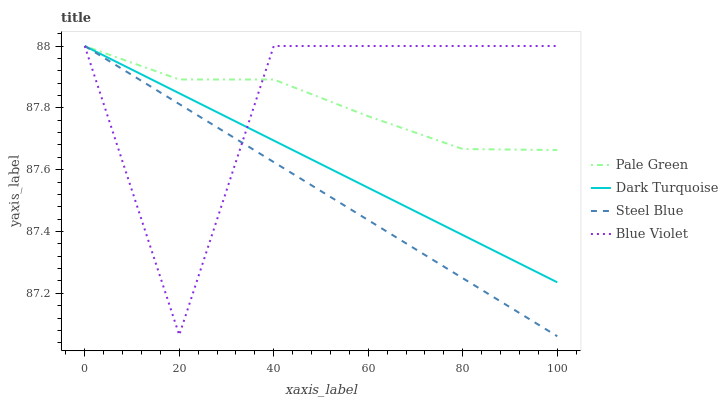Does Pale Green have the minimum area under the curve?
Answer yes or no. No. Does Pale Green have the maximum area under the curve?
Answer yes or no. No. Is Pale Green the smoothest?
Answer yes or no. No. Is Pale Green the roughest?
Answer yes or no. No. Does Pale Green have the lowest value?
Answer yes or no. No. 